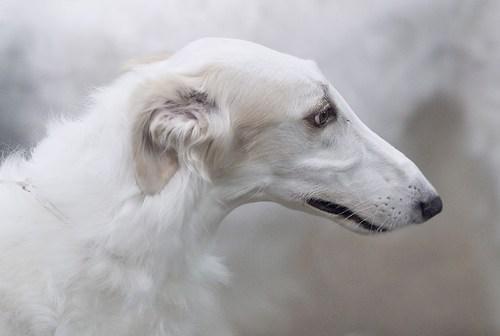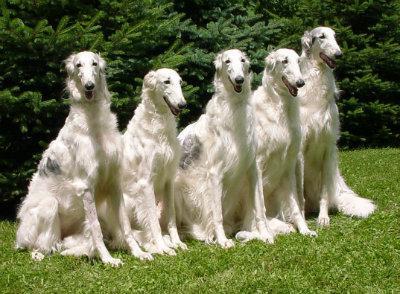The first image is the image on the left, the second image is the image on the right. Evaluate the accuracy of this statement regarding the images: "There are more than two dogs.". Is it true? Answer yes or no. Yes. The first image is the image on the left, the second image is the image on the right. Assess this claim about the two images: "There are no more than two dogs.". Correct or not? Answer yes or no. No. 